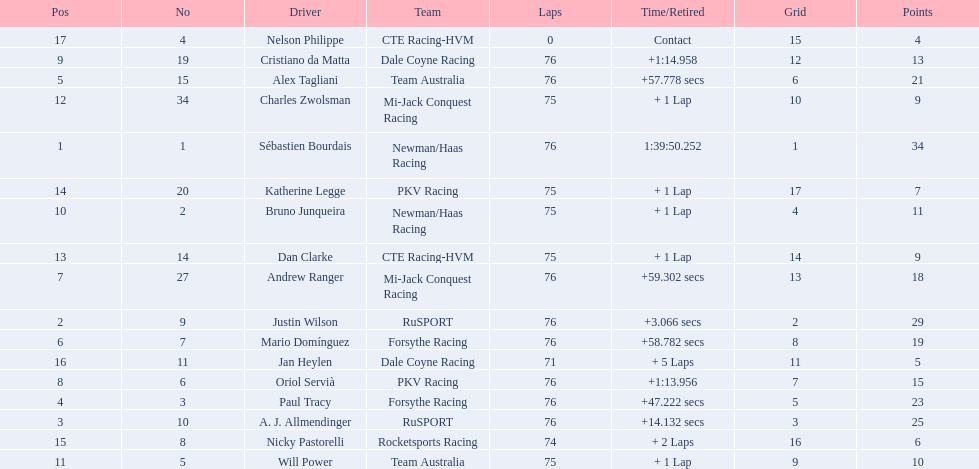Is there a driver named charles zwolsman? Charles Zwolsman. How many points did he acquire? 9. Were there any other entries that got the same number of points? 9. Who did that entry belong to? Dan Clarke. 